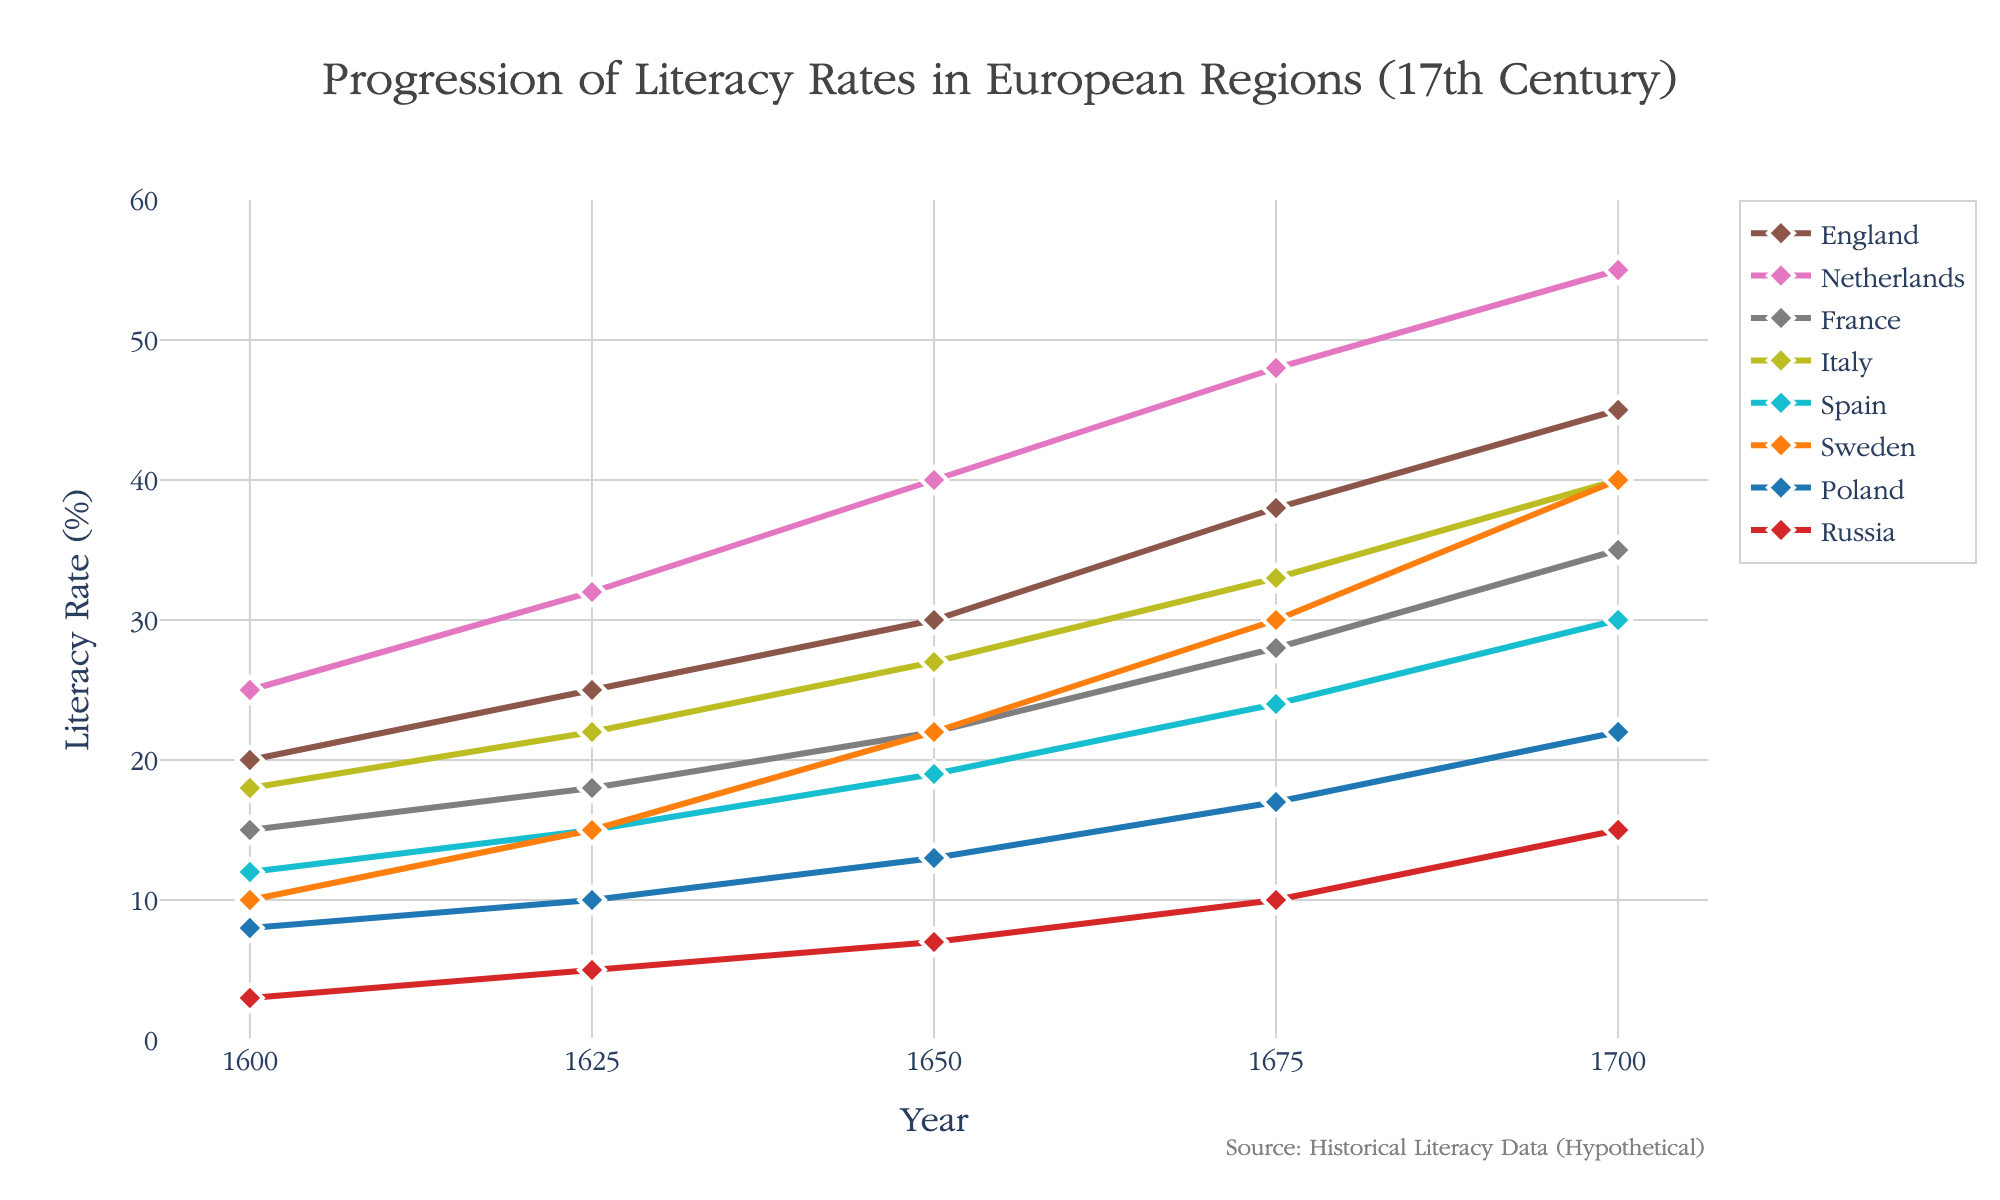what is the title of the figure? The title is generally located at the top of the figure. Referring to the text in this area, it reads "Progression of Literacy Rates in European Regions (17th Century)".
Answer: Progression of Literacy Rates in European Regions (17th Century) what is the literacy rate of Sweden in 1700? Locate the line corresponding to Sweden and follow it to the year 1700. According to the data point, the literacy rate for Sweden is 40%.
Answer: 40% which region had the lowest literacy rate in 1600? Compare the vertical position of data points in the year 1600 for all regions; the lowest point corresponds to Russia with a literacy rate of 3%.
Answer: Russia which two regions show the biggest increase in literacy rates from 1600 to 1700? For each region, subtract the literacy rate in 1600 from the literacy rate in 1700. Russia increases from 3% to 15% (12% increase), while the Netherlands increases from 25% to 55% (30% increase). The two regions with the largest increases in literacy rates are the Netherlands and Russia.
Answer: Netherlands and Russia how many regions had over a 30% literacy rate by the year 1700? Check the literacy rates for all regions in the year 1700. The regions with a literacy rate over 30% are England, Netherlands, France, Italy, Spain, and Sweden. Count the number of these regions, which equals 6.
Answer: 6 which region had the sharpest increase in literacy rate between 1650 and 1675? Find the difference in literacy rates between 1650 and 1675 for each region. Notice the changes: England (38-30=8), Netherlands (48-40=8), France (28-22=6), Italy (33-27=6), Spain (24-19=5), Sweden (30-22=8), Poland (17-13=4), Russia (10-7=3). The regions with the sharpest increase are England, Netherlands, and Sweden, each with an increase of 8%.
Answer: England, Netherlands, and Sweden which region consistently had the highest literacy rate throughout the entire century? Examine the literacy rates for all regions at each time point (1600, 1625, 1650, 1675, 1700). The Netherlands consistently has the highest rates at each interval.
Answer: Netherlands compare the changes in literacy rate of Italy and Spain between 1600 and 1700? Calculate the difference in literacy rates from 1600 to 1700 for Italy: 40 - 18 = 22%. For Spain: 30 - 12 = 18%. Italy had a change of 22%, while Spain had a change of 18%.
Answer: Italy increased by 22%, Spain increased by 18% what year showed the smallest gap in literacy rates between France and Italy? Calculate the differences between literacy rates for each year: 1600 (3%), 1625 (4%), 1650 (5%), 1675 (5%), 1700 (5%). The smallest gap is in 1600.
Answer: 1600 in which period did Russia see the most significant growth in literacy rates? Calculate the changes in literacy rates for Russia between each period: 1600-1625 (2%), 1625-1650 (2%), 1650-1675 (3%), 1675-1700 (5%). The most significant growth occurred between 1675 and 1700 with a 5% increase.
Answer: 1675-1700 